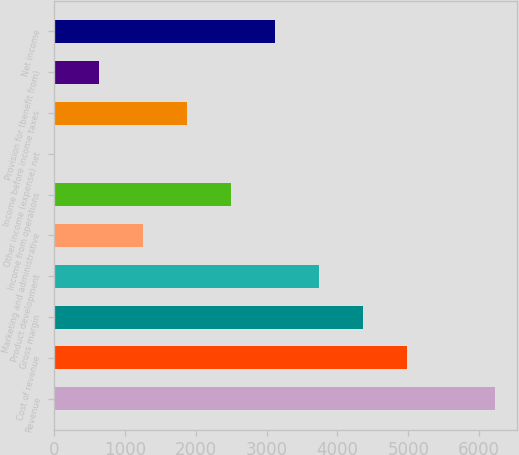<chart> <loc_0><loc_0><loc_500><loc_500><bar_chart><fcel>Revenue<fcel>Cost of revenue<fcel>Gross margin<fcel>Product development<fcel>Marketing and administrative<fcel>Income from operations<fcel>Other income (expense) net<fcel>Income before income taxes<fcel>Provision for (benefit from)<fcel>Net income<nl><fcel>6224<fcel>4982.4<fcel>4361.6<fcel>3740.8<fcel>1257.6<fcel>2499.2<fcel>16<fcel>1878.4<fcel>636.8<fcel>3120<nl></chart> 